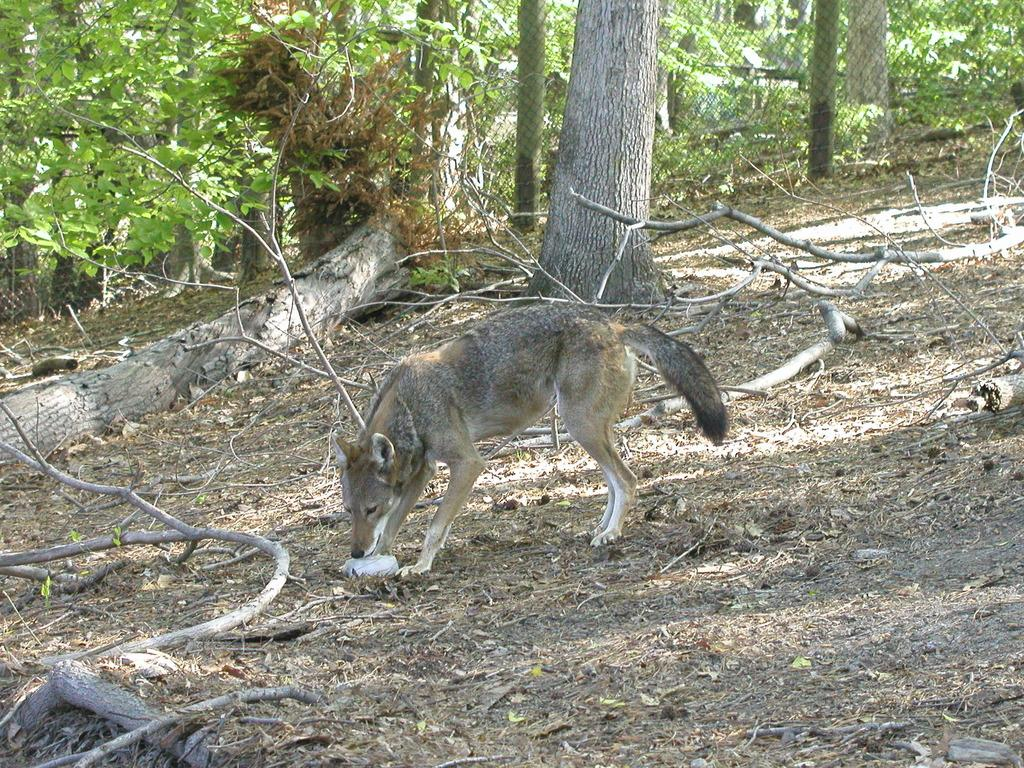What type of animal can be seen in the image? There is an animal in the image, but its specific type cannot be determined from the provided facts. What is on the ground in the image? There are tree branches on the ground in the image. What can be seen in the distance in the image? There are trees visible in the background of the image. What type of barrier is present in the image? There is a fence in the image. What type of food is being advertised in the image? There is no food or advertisement present in the image. 